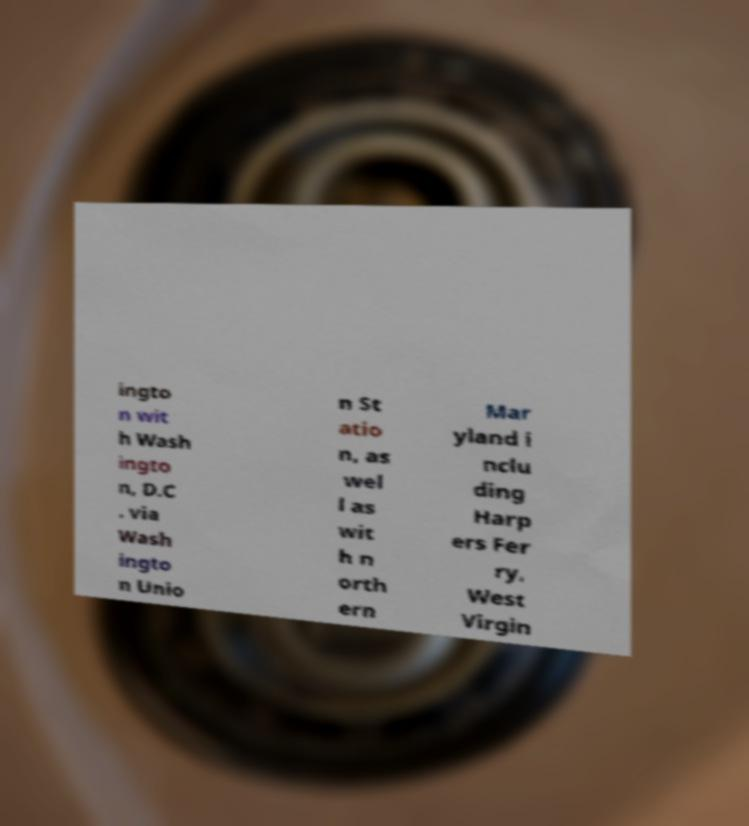There's text embedded in this image that I need extracted. Can you transcribe it verbatim? ingto n wit h Wash ingto n, D.C . via Wash ingto n Unio n St atio n, as wel l as wit h n orth ern Mar yland i nclu ding Harp ers Fer ry, West Virgin 